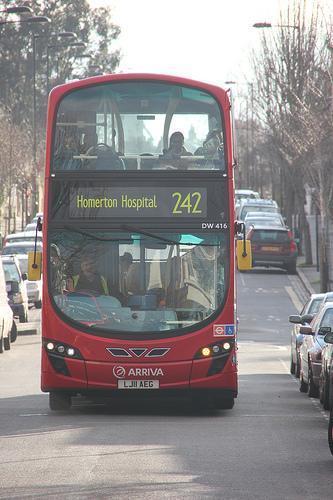How many buses are in the photo?
Give a very brief answer. 1. 